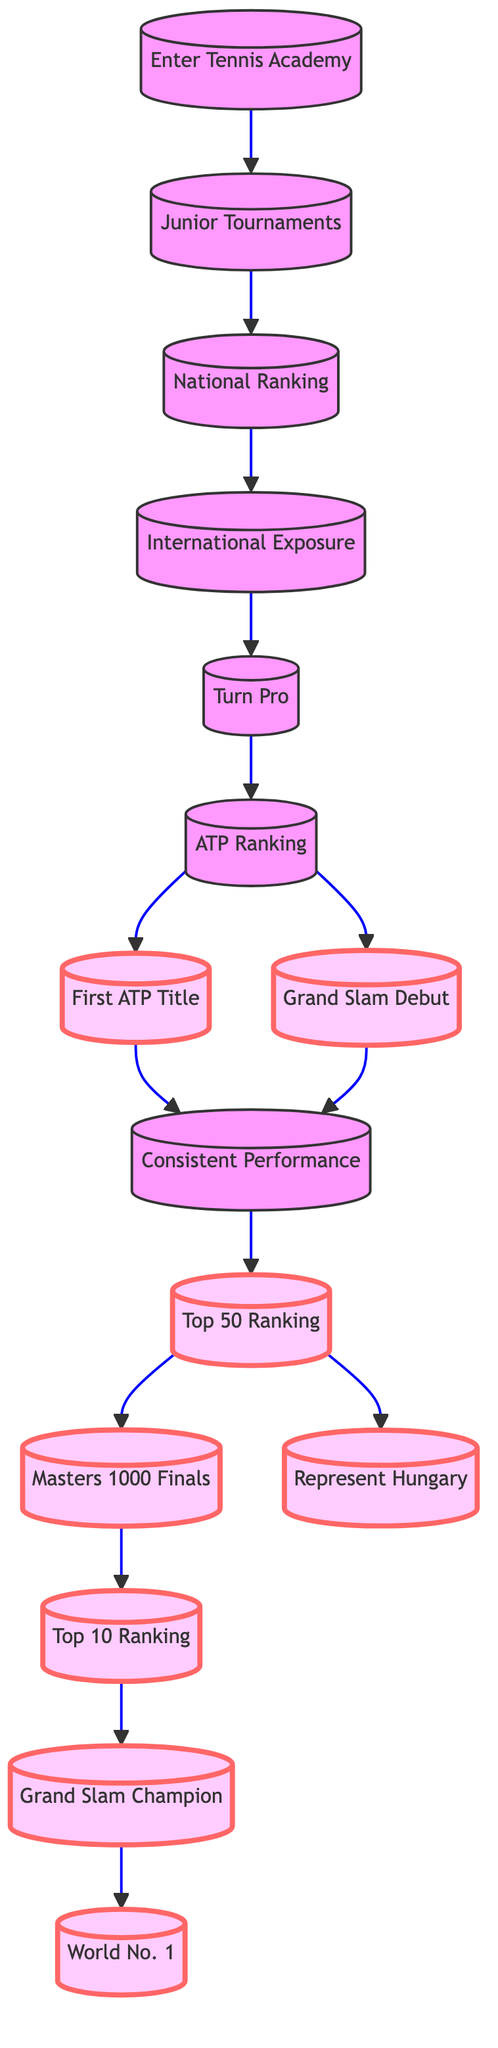What is the first milestone in the career progression? The first milestone is listed as "First ATP Title" at node 7. It is the first key achievement in the progression of a tennis career according to the diagram.
Answer: First ATP Title How many nodes are in the career progression diagram? The career progression diagram contains a total of 15 nodes representing various stages and milestones in a tennis player's career.
Answer: 15 What is the relationship between "Turn Pro" and "ATP Ranking"? "Turn Pro" (node 5) leads to "ATP Ranking" (node 6), indicating that after turning professional, a player begins to earn an ATP ranking.
Answer: Turn Pro → ATP Ranking Which milestone comes after "Grand Slam Champion"? "World No. 1" is the milestone that occurs after "Grand Slam Champion" (node 14), indicating it is a subsequent achievement in a player's career.
Answer: World No. 1 What is the last milestone in the career progression? The last milestone is "World No. 1" at node 15, representing the ultimate status a player can achieve in their tennis career as per the diagram.
Answer: World No. 1 How many edges are there connecting the nodes in the diagram? The diagram has a total of 14 edges that depict the connections and progression from one milestone to another in the career path.
Answer: 14 What milestone requires an ATP ranking? The "Grand Slam Debut" at node 8 requires an ATP ranking, as a player must first earn an ATP ranking (node 6) to qualify for this event.
Answer: Grand Slam Debut Which node enables representation of Hungary in international competitions? "Represent Hungary" at node 12 is the milestone that allows a player to compete for their country in events like the Davis Cup or Olympics.
Answer: Represent Hungary What do you achieve after reaching the "Top 50 Ranking"? After achieving the "Top 50 Ranking" at node 10, a player can compete in "Masters 1000 Finals" (node 11) and also "Represent Hungary" (node 12) in international matches.
Answer: Masters 1000 Finals, Represent Hungary 